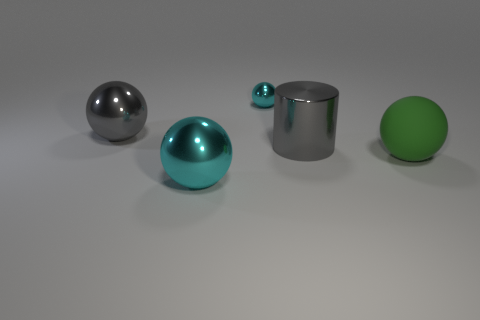Subtract all gray blocks. How many cyan balls are left? 2 Subtract 2 balls. How many balls are left? 2 Subtract all green balls. How many balls are left? 3 Subtract all big green matte balls. How many balls are left? 3 Add 2 small metallic objects. How many objects exist? 7 Subtract all brown balls. Subtract all red cylinders. How many balls are left? 4 Subtract all balls. How many objects are left? 1 Add 2 big yellow spheres. How many big yellow spheres exist? 2 Subtract 0 brown cylinders. How many objects are left? 5 Subtract all red shiny objects. Subtract all cyan shiny spheres. How many objects are left? 3 